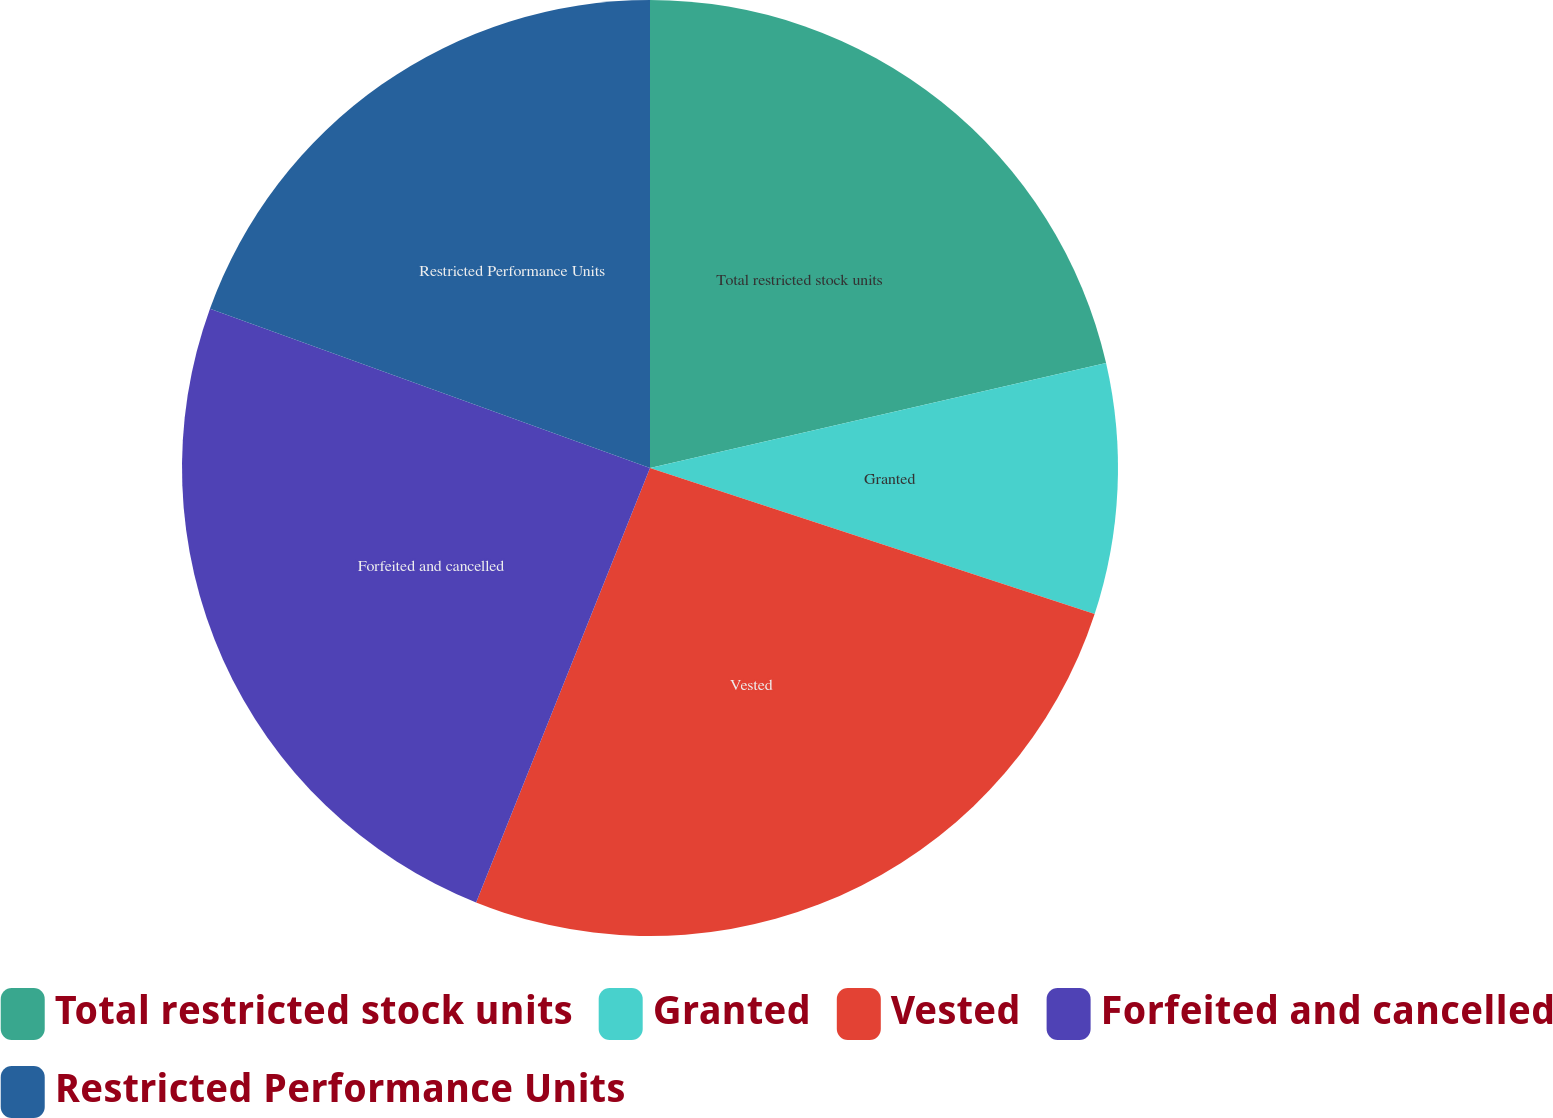Convert chart. <chart><loc_0><loc_0><loc_500><loc_500><pie_chart><fcel>Total restricted stock units<fcel>Granted<fcel>Vested<fcel>Forfeited and cancelled<fcel>Restricted Performance Units<nl><fcel>21.4%<fcel>8.65%<fcel>26.01%<fcel>24.47%<fcel>19.47%<nl></chart> 